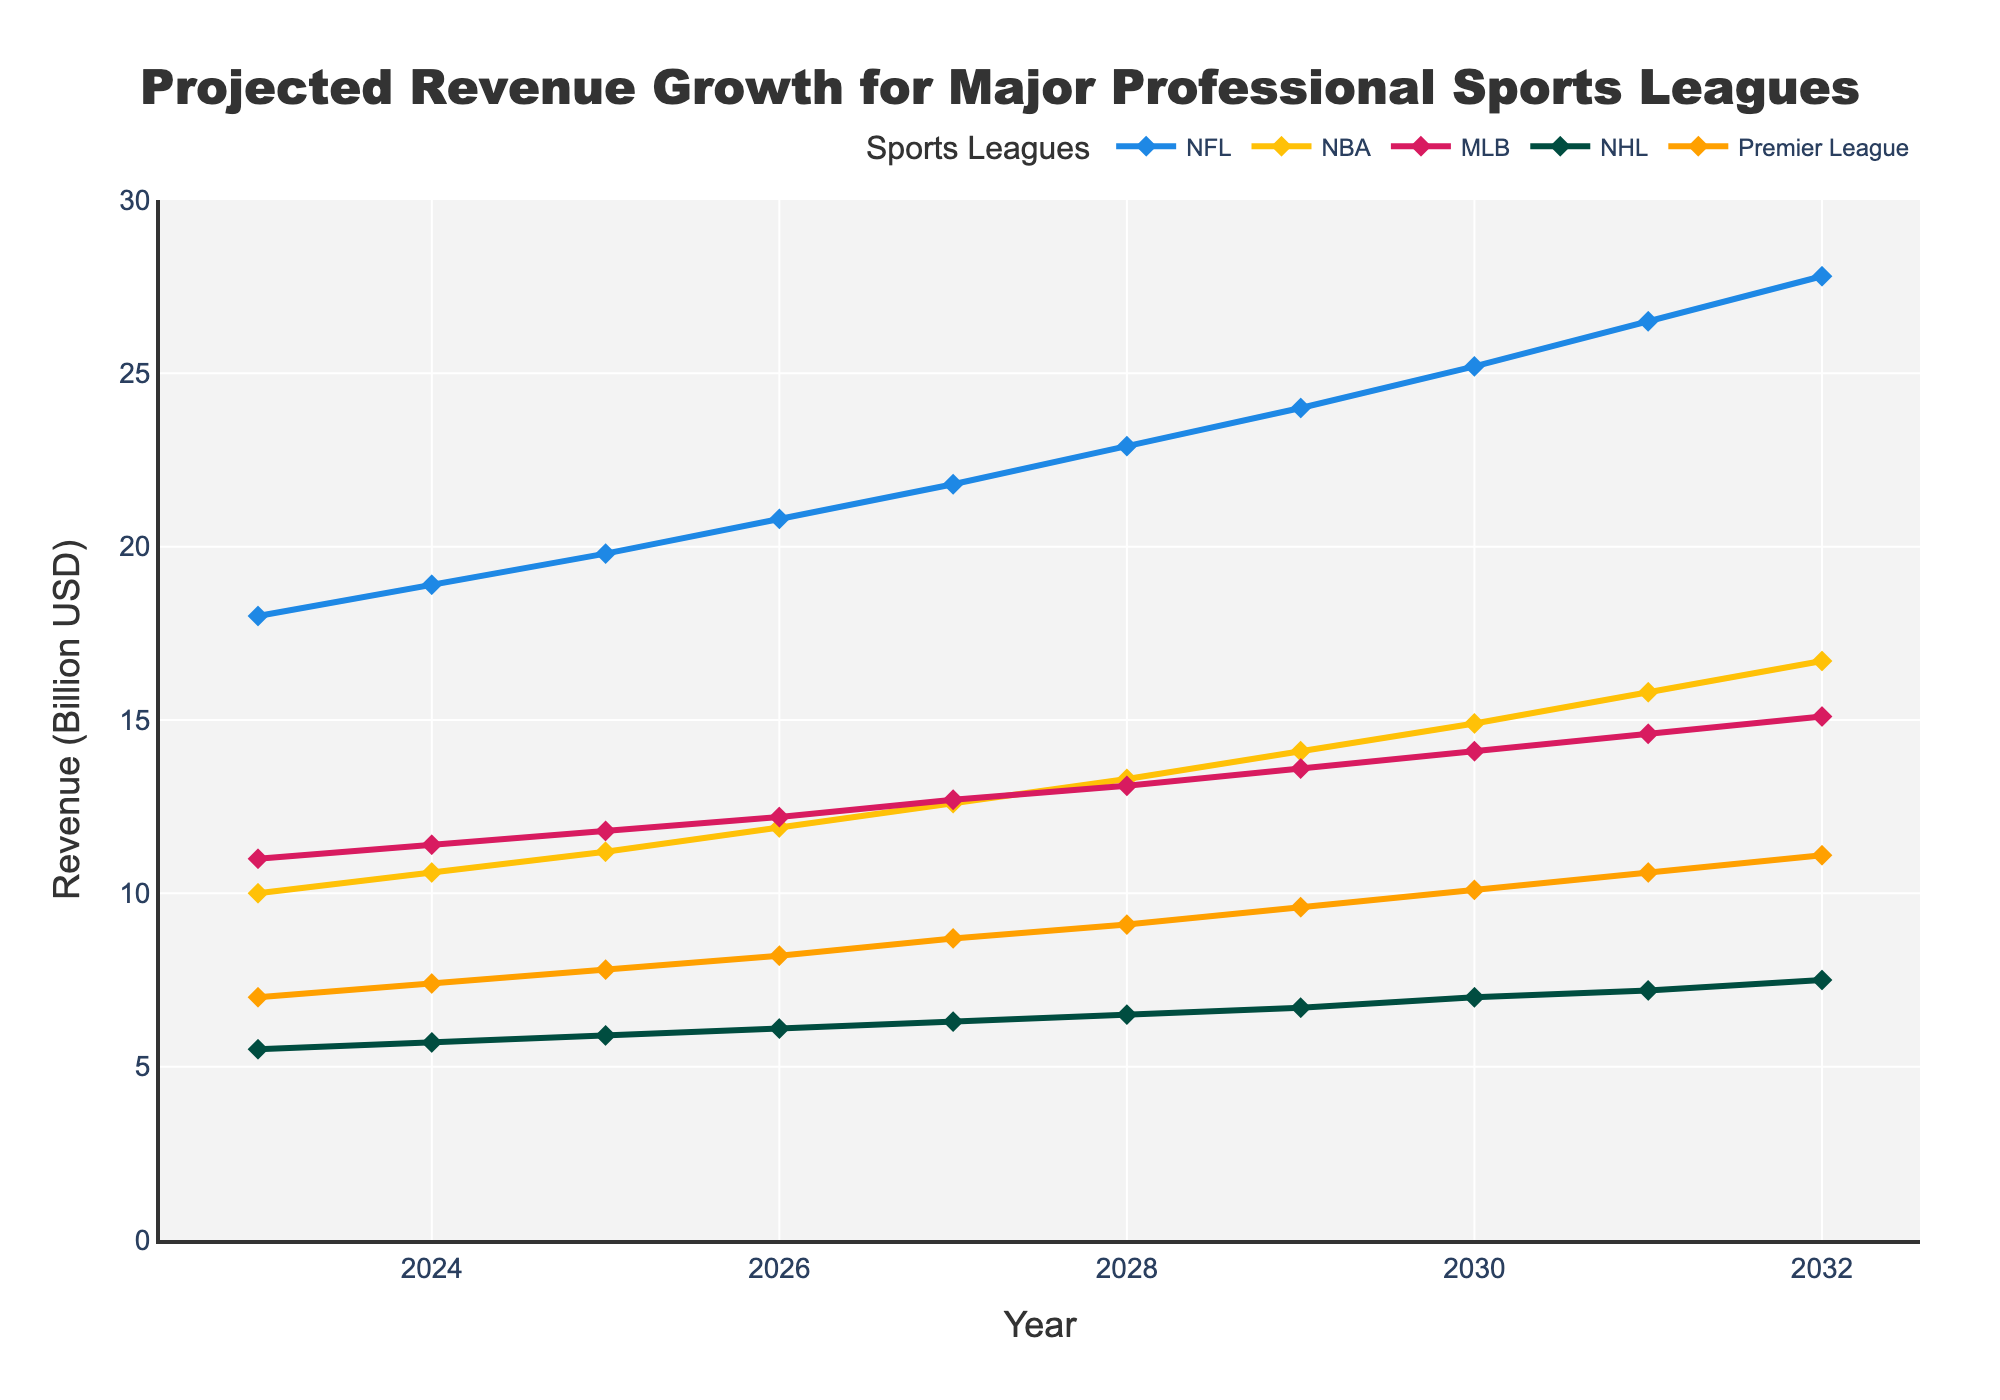What's the title of the chart? The title is displayed at the top of the chart.
Answer: Projected Revenue Growth for Major Professional Sports Leagues What is the projected revenue for the NFL in 2027? Find the 2027 data point for NFL.
Answer: 21.8 billion USD What is the difference in revenue between the NHL and the Premier League in 2030? Locate the 2030 data points for the NHL and Premier League and calculate the difference. Premier League: 10.1 billion USD, NHL: 7.0 billion USD. Difference: 10.1 - 7.0.
Answer: 3.1 billion USD Which sports league is predicted to have the highest revenue in 2032? Compare the 2032 data points for all leagues. NFL has 27.8 billion USD, which is the highest.
Answer: NFL How does the NBA's revenue growth from 2023 to 2032 compare with that of the MLB? Compute the revenue growth for NBA and MLB from 2023 to 2032. NBA: 16.7 - 10.0 = 6.7 billion USD, MLB: 15.1 - 11.0 = 4.1 billion USD. NBA's growth is more significant.
Answer: NBA's growth is higher Between 2026 and 2028, which league shows the most significant revenue increase, and by how much? Compute the difference for each league between 2026 and 2028: NFL: 22.9-20.8 = 2.1, NBA: 13.3-11.9 = 1.4, MLB: 13.1-12.2 = 0.9, NHL: 6.5-6.1 = 0.4, Premier League: 9.1-8.2 = 0.9. NFL shows the largest increase.
Answer: NFL, 2.1 billion USD In which year is the revenue for the NHL projected to reach 7 billion USD? Locate the year when NHL's data point is 7 billion USD.
Answer: 2030 What is the average projected revenue growth for the Premier League from 2023 to 2026? Calculate the average projected revenue for the years 2023, 2024, 2025, and 2026, and then find its average: (7.0 + 7.4 + 7.8 + 8.2) / 4.
Answer: 7.6 billion USD Which league is expected to surpass the 20 billion USD revenue mark first, and in which year? Find the year when each league first exceeds 20 billion USD. NFL first surpasses 20 billion USD in 2025.
Answer: NFL, 2025 How many leagues are projected to have at least 10 billion USD in revenue by 2032? Check the 2032 data points for each league and count how many are 10 billion USD or more. NFL, NBA, MLB, and Premier League exceed 10 billion USD.
Answer: 4 leagues 